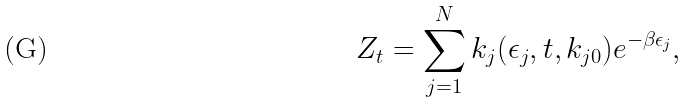<formula> <loc_0><loc_0><loc_500><loc_500>Z _ { t } = \sum ^ { N } _ { j = 1 } k _ { j } ( \epsilon _ { j } , t , k _ { j 0 } ) e ^ { - \beta \epsilon _ { j } } ,</formula> 